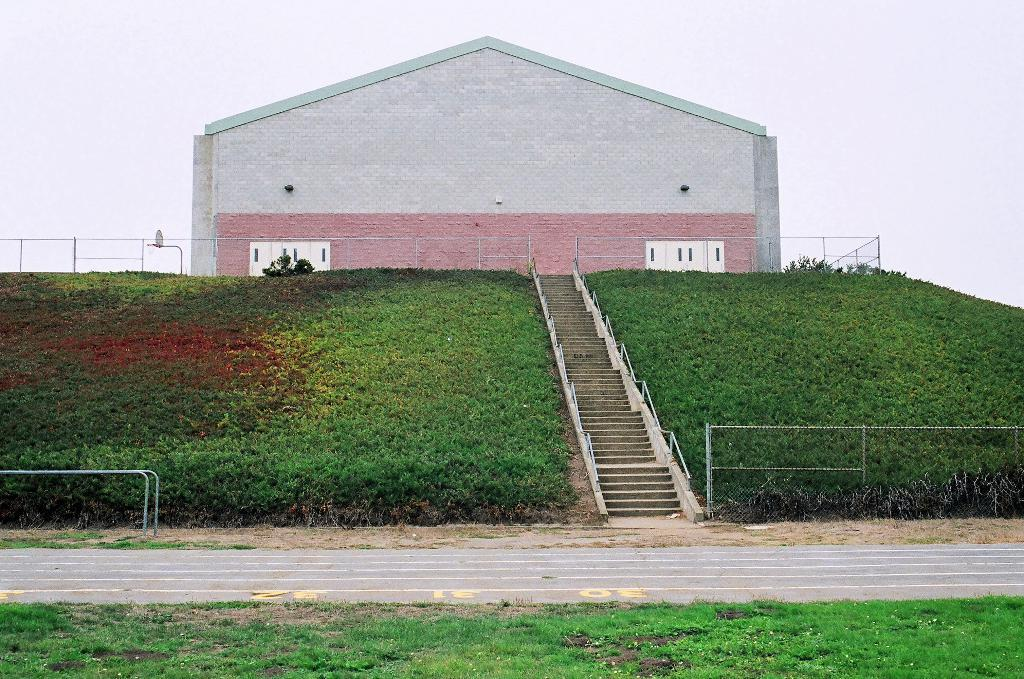What type of vegetation can be seen in the image? There is grass in the image. What type of pathway is present in the image? There is a road in the image. What architectural feature allows for elevation changes in the image? There are steps in the image. What structures are used to enclose or separate areas in the image? There are fences in the image. What long, thin objects are present in the image? There are rods in the image. What solid structure can be seen in the image? There is a wall in the image. What inanimate objects can be seen in the image? There are objects in the image. What can be seen in the distance in the image? The sky is visible in the background of the image. What type of skin condition can be seen on the insect in the image? There are no insects present in the image, so it is not possible to determine if any have a skin condition. Can you see an airplane flying in the sky in the image? There is no airplane visible in the sky in the image. 